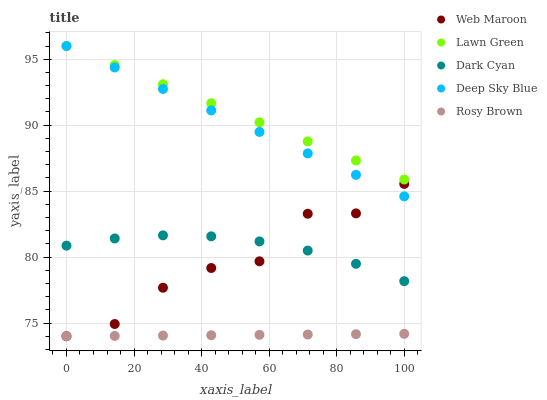Does Rosy Brown have the minimum area under the curve?
Answer yes or no. Yes. Does Lawn Green have the maximum area under the curve?
Answer yes or no. Yes. Does Lawn Green have the minimum area under the curve?
Answer yes or no. No. Does Rosy Brown have the maximum area under the curve?
Answer yes or no. No. Is Rosy Brown the smoothest?
Answer yes or no. Yes. Is Web Maroon the roughest?
Answer yes or no. Yes. Is Lawn Green the smoothest?
Answer yes or no. No. Is Lawn Green the roughest?
Answer yes or no. No. Does Rosy Brown have the lowest value?
Answer yes or no. Yes. Does Lawn Green have the lowest value?
Answer yes or no. No. Does Deep Sky Blue have the highest value?
Answer yes or no. Yes. Does Rosy Brown have the highest value?
Answer yes or no. No. Is Rosy Brown less than Deep Sky Blue?
Answer yes or no. Yes. Is Lawn Green greater than Dark Cyan?
Answer yes or no. Yes. Does Web Maroon intersect Dark Cyan?
Answer yes or no. Yes. Is Web Maroon less than Dark Cyan?
Answer yes or no. No. Is Web Maroon greater than Dark Cyan?
Answer yes or no. No. Does Rosy Brown intersect Deep Sky Blue?
Answer yes or no. No. 